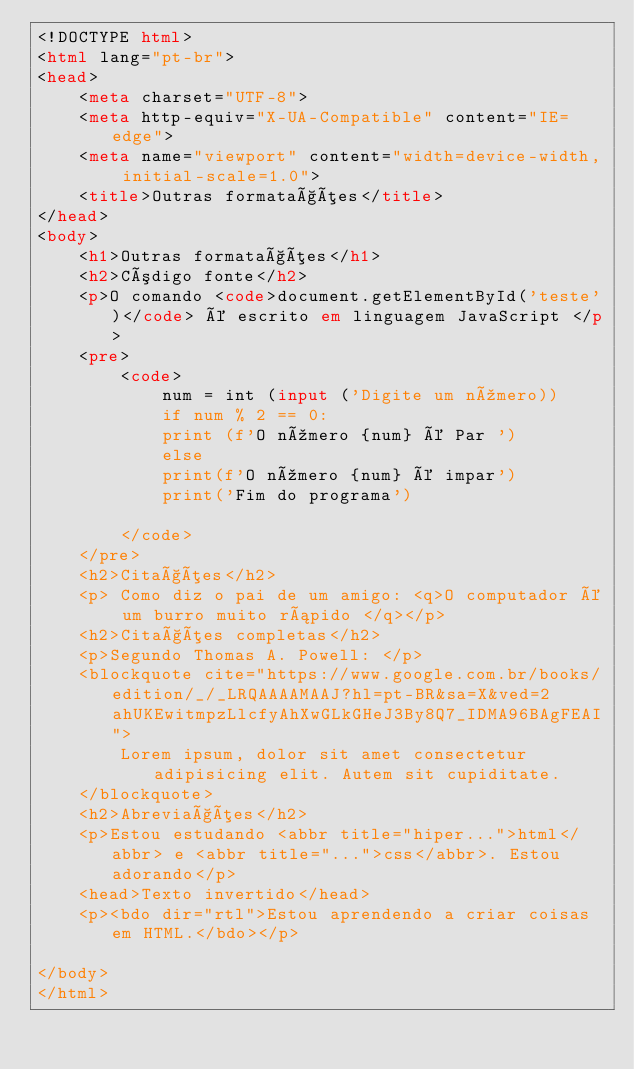Convert code to text. <code><loc_0><loc_0><loc_500><loc_500><_HTML_><!DOCTYPE html>
<html lang="pt-br">
<head>
    <meta charset="UTF-8">
    <meta http-equiv="X-UA-Compatible" content="IE=edge">
    <meta name="viewport" content="width=device-width, initial-scale=1.0">
    <title>Outras formatações</title>
</head>
<body>
    <h1>Outras formatações</h1>
    <h2>Código fonte</h2>
    <p>O comando <code>document.getElementById('teste')</code> é escrito em linguagem JavaScript </p>
    <pre>
        <code>
            num = int (input ('Digite um número))
            if num % 2 == 0:
            print (f'O número {num} é Par ')
            else
            print(f'O número {num} é impar')
            print('Fim do programa')
        
        </code>
    </pre>
    <h2>Citações</h2>
    <p> Como diz o pai de um amigo: <q>O computador é um burro muito rápido </q></p>
    <h2>Citações completas</h2>
    <p>Segundo Thomas A. Powell: </p>
    <blockquote cite="https://www.google.com.br/books/edition/_/_LRQAAAAMAAJ?hl=pt-BR&sa=X&ved=2ahUKEwitmpzLlcfyAhXwGLkGHeJ3By8Q7_IDMA96BAgFEAI">
        Lorem ipsum, dolor sit amet consectetur adipisicing elit. Autem sit cupiditate.
    </blockquote>
    <h2>Abreviações</h2>
    <p>Estou estudando <abbr title="hiper...">html</abbr> e <abbr title="...">css</abbr>. Estou adorando</p>
    <head>Texto invertido</head>
    <p><bdo dir="rtl">Estou aprendendo a criar coisas em HTML.</bdo></p>

</body>
</html></code> 